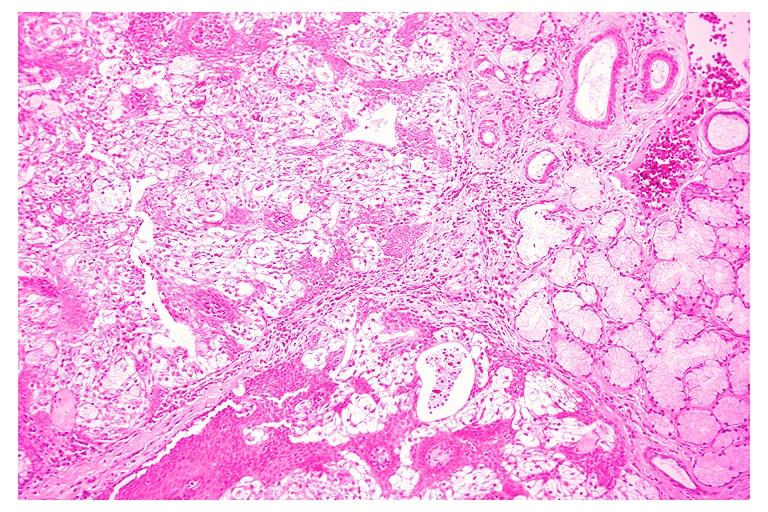does underdevelopment show mucoepidermoid carcinoma?
Answer the question using a single word or phrase. No 